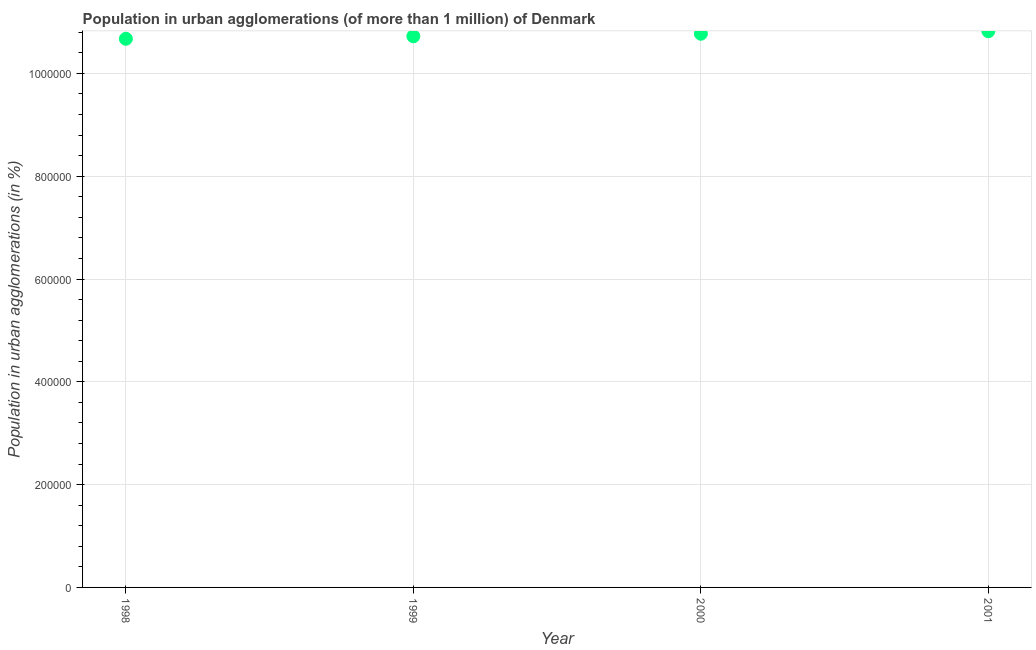What is the population in urban agglomerations in 1998?
Give a very brief answer. 1.07e+06. Across all years, what is the maximum population in urban agglomerations?
Ensure brevity in your answer.  1.08e+06. Across all years, what is the minimum population in urban agglomerations?
Provide a short and direct response. 1.07e+06. What is the sum of the population in urban agglomerations?
Provide a short and direct response. 4.30e+06. What is the difference between the population in urban agglomerations in 1999 and 2001?
Your response must be concise. -9848. What is the average population in urban agglomerations per year?
Your answer should be compact. 1.07e+06. What is the median population in urban agglomerations?
Make the answer very short. 1.07e+06. In how many years, is the population in urban agglomerations greater than 40000 %?
Provide a short and direct response. 4. What is the ratio of the population in urban agglomerations in 2000 to that in 2001?
Offer a terse response. 1. Is the population in urban agglomerations in 1999 less than that in 2000?
Keep it short and to the point. Yes. Is the difference between the population in urban agglomerations in 1998 and 2001 greater than the difference between any two years?
Offer a very short reply. Yes. What is the difference between the highest and the second highest population in urban agglomerations?
Your answer should be compact. 4928. What is the difference between the highest and the lowest population in urban agglomerations?
Ensure brevity in your answer.  1.47e+04. In how many years, is the population in urban agglomerations greater than the average population in urban agglomerations taken over all years?
Keep it short and to the point. 2. How many years are there in the graph?
Ensure brevity in your answer.  4. What is the title of the graph?
Your response must be concise. Population in urban agglomerations (of more than 1 million) of Denmark. What is the label or title of the X-axis?
Provide a short and direct response. Year. What is the label or title of the Y-axis?
Provide a short and direct response. Population in urban agglomerations (in %). What is the Population in urban agglomerations (in %) in 1998?
Your answer should be compact. 1.07e+06. What is the Population in urban agglomerations (in %) in 1999?
Ensure brevity in your answer.  1.07e+06. What is the Population in urban agglomerations (in %) in 2000?
Your answer should be very brief. 1.08e+06. What is the Population in urban agglomerations (in %) in 2001?
Offer a terse response. 1.08e+06. What is the difference between the Population in urban agglomerations (in %) in 1998 and 1999?
Offer a very short reply. -4890. What is the difference between the Population in urban agglomerations (in %) in 1998 and 2000?
Make the answer very short. -9810. What is the difference between the Population in urban agglomerations (in %) in 1998 and 2001?
Offer a terse response. -1.47e+04. What is the difference between the Population in urban agglomerations (in %) in 1999 and 2000?
Make the answer very short. -4920. What is the difference between the Population in urban agglomerations (in %) in 1999 and 2001?
Provide a short and direct response. -9848. What is the difference between the Population in urban agglomerations (in %) in 2000 and 2001?
Offer a terse response. -4928. What is the ratio of the Population in urban agglomerations (in %) in 1999 to that in 2000?
Your answer should be very brief. 0.99. What is the ratio of the Population in urban agglomerations (in %) in 2000 to that in 2001?
Keep it short and to the point. 0.99. 